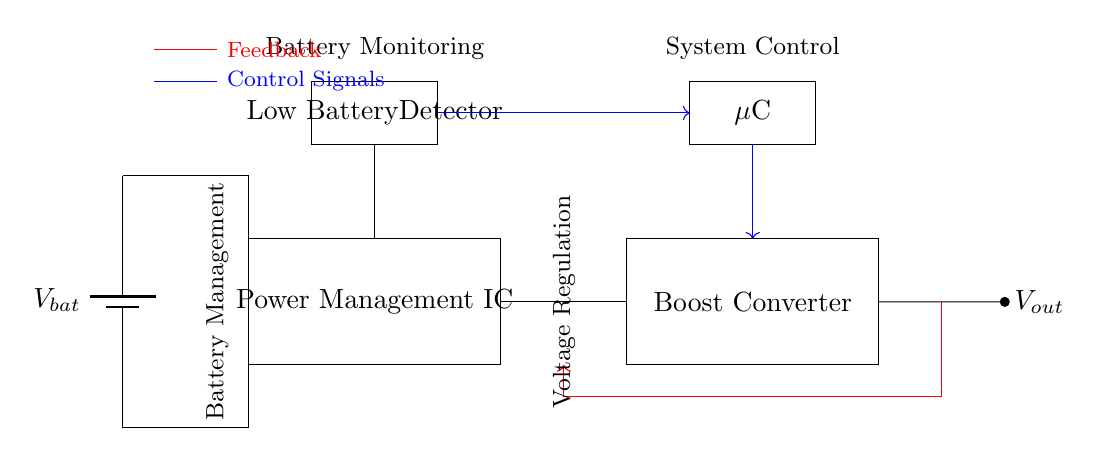What is the main function of the Power Management IC? The Power Management IC's main function is to manage power distribution and regulation in the circuit, ensuring optimized performance for portable devices.
Answer: Manage power distribution What is the role of the Low Battery Detector? The Low Battery Detector monitors the battery voltage and signals when the voltage falls below a certain threshold, alerting the system to conserve energy or shut down to prevent damage.
Answer: Monitor battery voltage How many output connections does the Boost Converter have? The Boost Converter has one output connection that delivers the boosted voltage to the load, indicated by the output line labeled as Vout.
Answer: One What does the red arrow indicate in the circuit? The red arrow indicates a feedback signal that provides information from the output back to the system to regulate voltage and improve efficiency.
Answer: Feedback signal Which component receives control signals from the Low Battery Detector? The Microcontroller receives control signals from the Low Battery Detector, allowing it to process the battery status and manage the system's power state.
Answer: Microcontroller What is the purpose of the feedback connection between the Boost Converter and Power Management IC? The feedback connection allows the system to adjust the output voltage and enhance the efficiency of the power conversion process by monitoring real-time conditions.
Answer: Adjust voltage What type of circuit is represented by this diagram? This circuit represents a power management circuit specifically designed for long-term battery life in portable metabolic analysis devices, focusing on battery efficiency and voltage regulation.
Answer: Power management circuit 